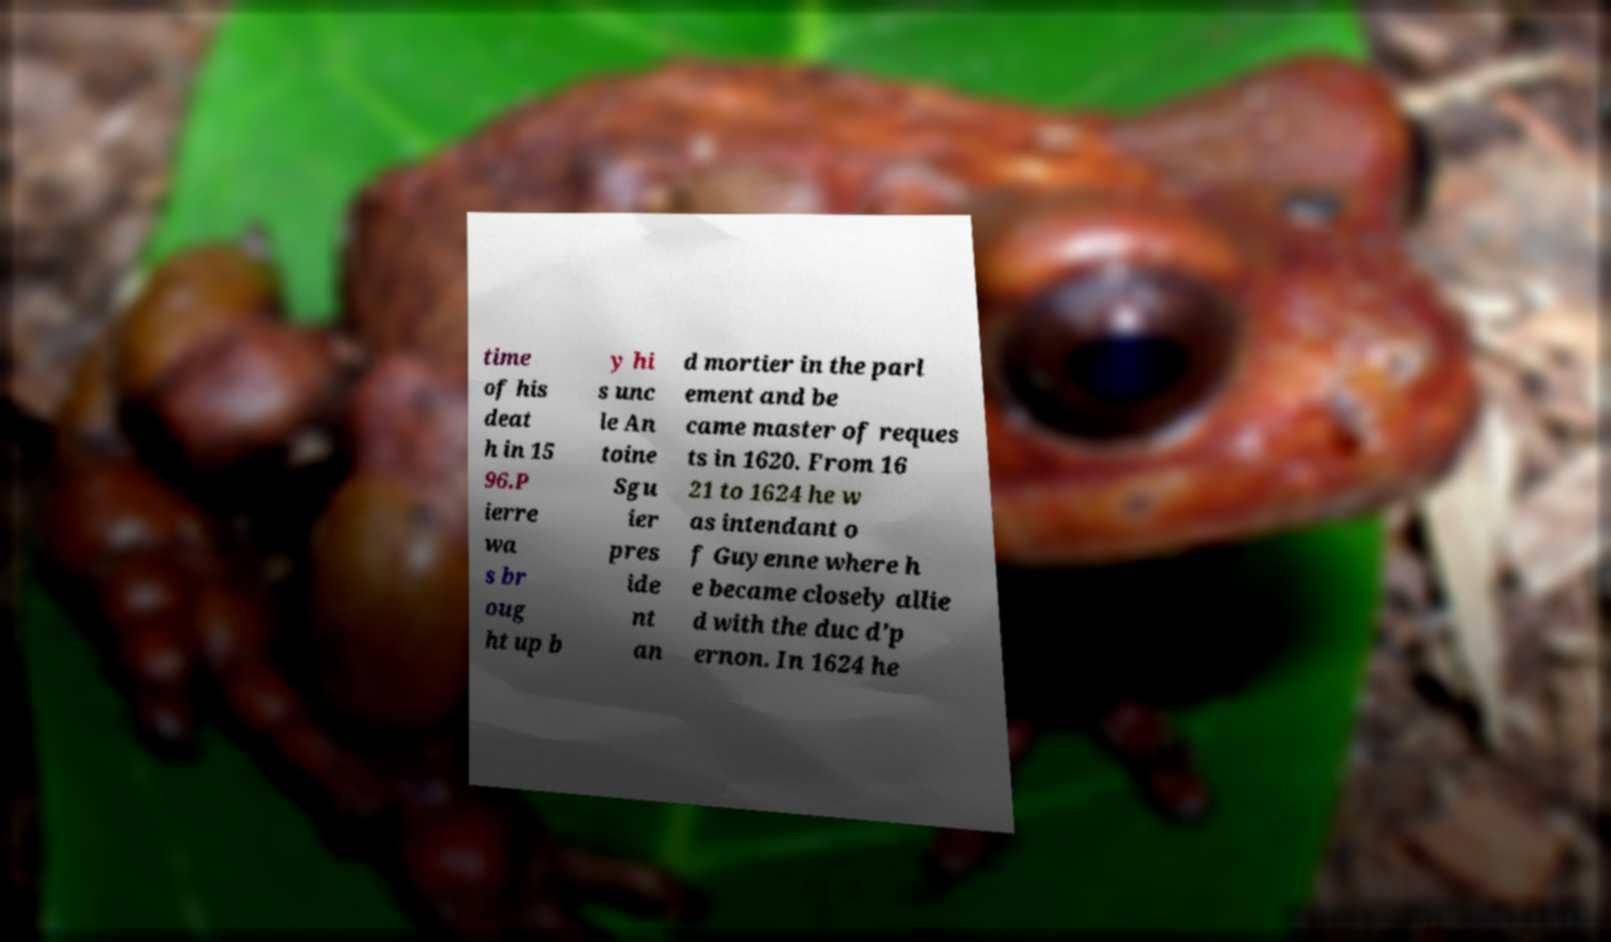Can you accurately transcribe the text from the provided image for me? time of his deat h in 15 96.P ierre wa s br oug ht up b y hi s unc le An toine Sgu ier pres ide nt an d mortier in the parl ement and be came master of reques ts in 1620. From 16 21 to 1624 he w as intendant o f Guyenne where h e became closely allie d with the duc d'p ernon. In 1624 he 